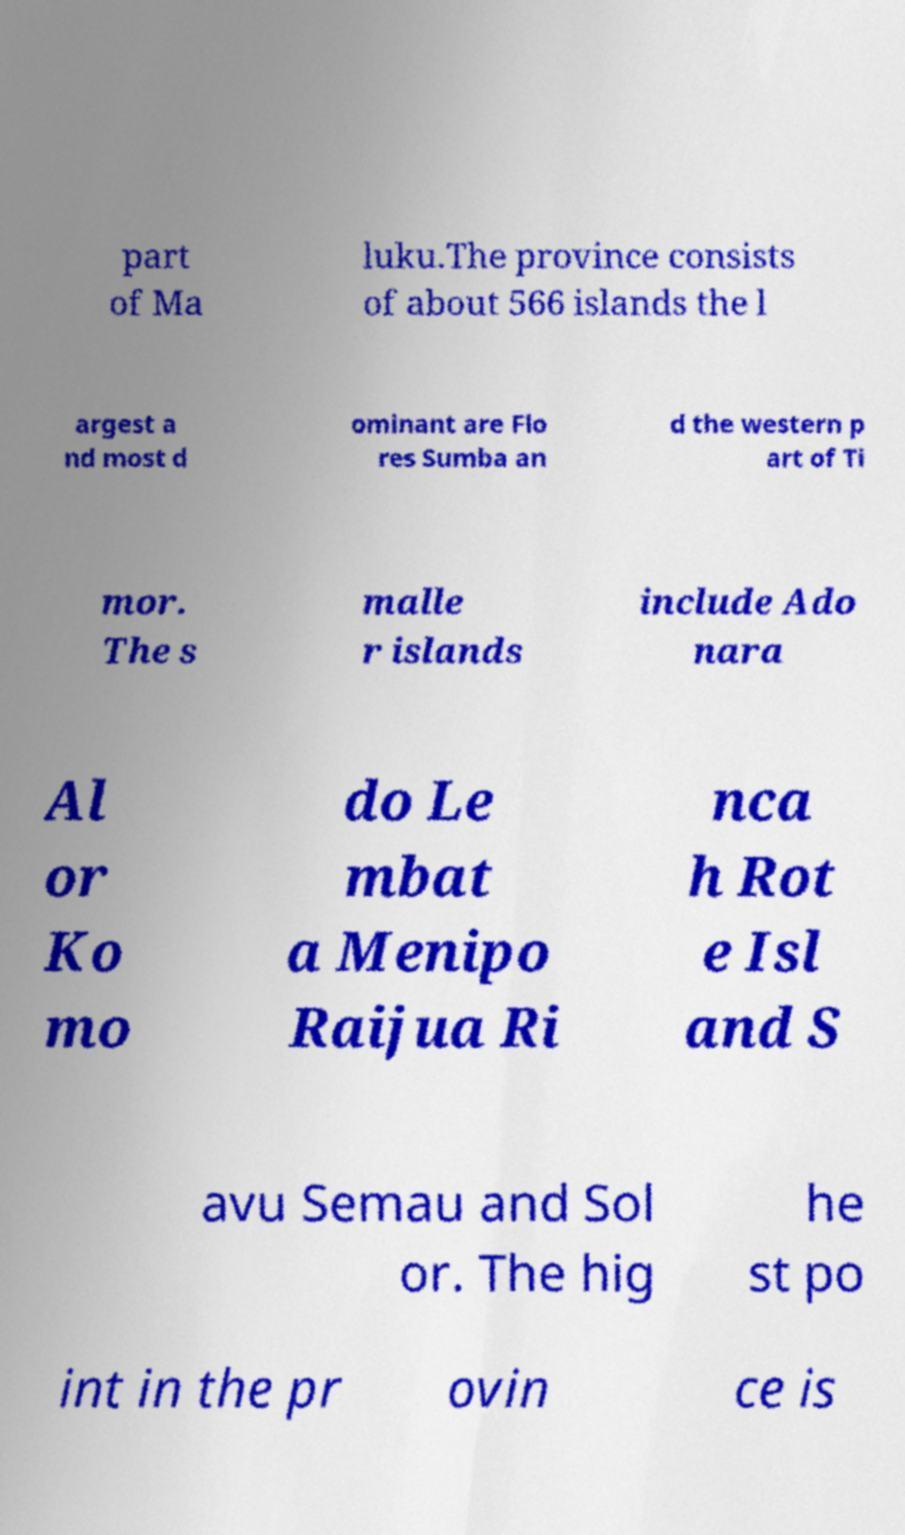Please identify and transcribe the text found in this image. part of Ma luku.The province consists of about 566 islands the l argest a nd most d ominant are Flo res Sumba an d the western p art of Ti mor. The s malle r islands include Ado nara Al or Ko mo do Le mbat a Menipo Raijua Ri nca h Rot e Isl and S avu Semau and Sol or. The hig he st po int in the pr ovin ce is 